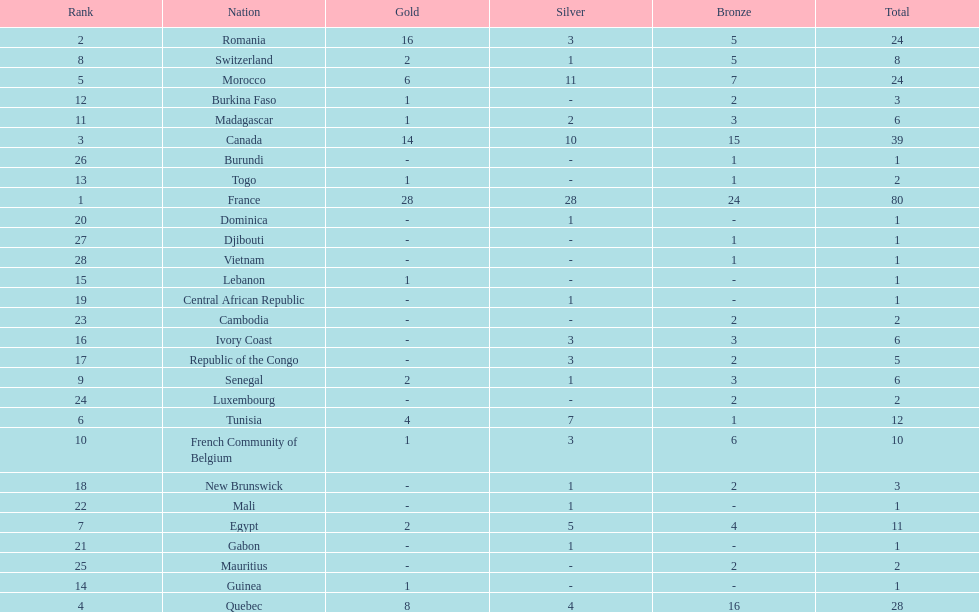Who placed in first according to medals? France. 